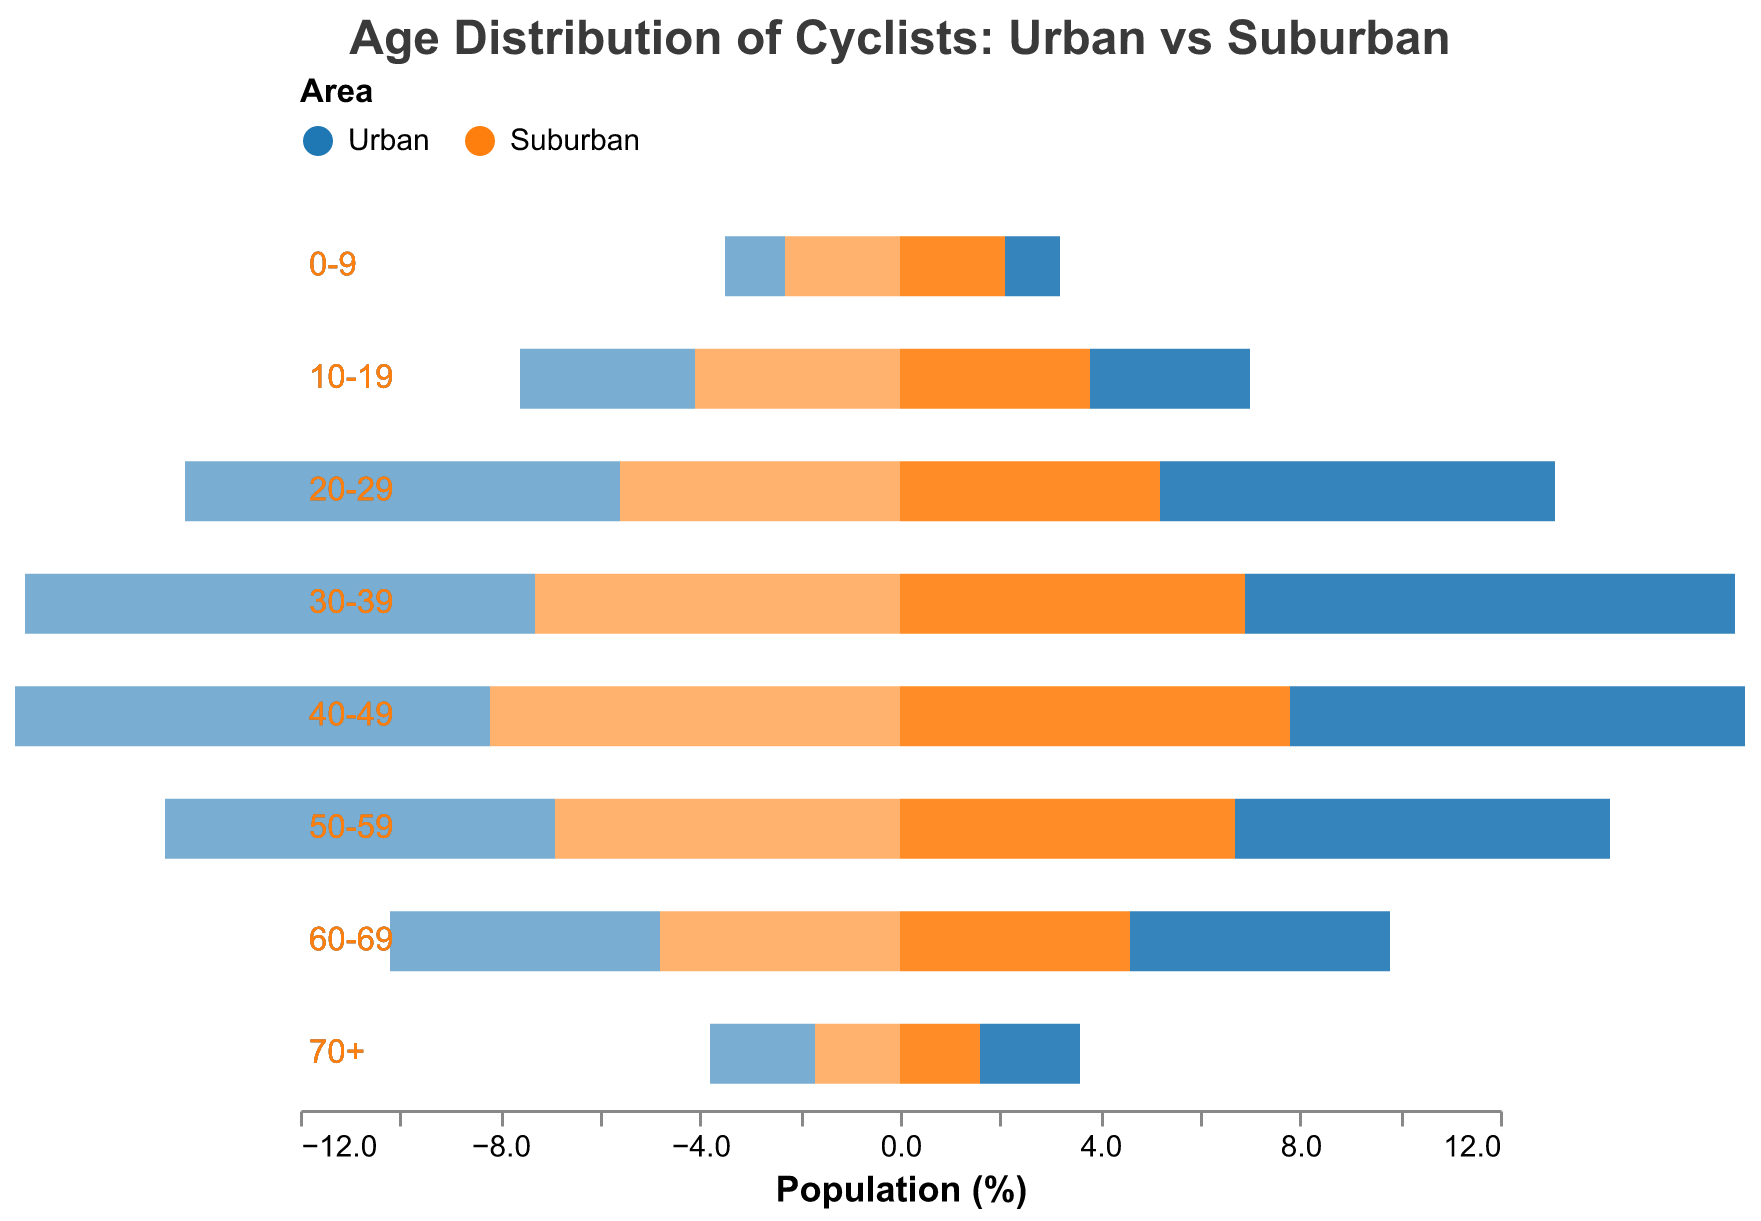What is the title of the figure? The title is located at the top of the figure, reading "Age Distribution of Cyclists: Urban vs Suburban".
Answer: Age Distribution of Cyclists: Urban vs Suburban How many age groups are presented in the figure? By looking at the y-axis, there are eight age groups displayed, ranging from "0-9" to "70+".
Answer: Eight Which area has a higher percentage of cyclists in the 30-39 age group, urban or suburban? By comparing the bar lengths for the 30-39 age group, the urban area has longer bars (10.2 for males and 9.8 for females versus 7.3 and 6.9 for suburban).
Answer: Urban In the 50-59 age group, is there more male or female cyclists in urban areas? For the 50-59 age group, compare the male and female urban bars. Urban male is 7.8% while urban female is 7.5%.
Answer: Male What is the difference in the percentage of urban male cyclists between the 20-29 and 60-69 age groups? Subtract the 60-69 percentage (5.4) from the 20-29 percentage (8.7).
Answer: 3.3 What is the combined percentage of suburban male and female cyclists in the 40-49 age group? Add the percentage of suburban males (8.2) and females (7.8) in the 40-49 age group.
Answer: 16 Which gender has a higher percentage across all age groups in suburban areas? Summing the percentages for each gender, males have higher values across all age groups in suburban areas.
Answer: Male What trend can you observe in the distribution of cyclists as age increases in urban areas? The percentage generally decreases as the age increases, indicating fewer older cyclists in urban areas.
Answer: Decreasing trend How does the percentage of cyclists in the 10-19 age group compare between urban and suburban areas? For the 10-19 age group, compare the combined percentages of urban (6.7) and suburban (7.9). The suburban area has a higher percentage.
Answer: Suburban has higher percentage What is the percentage difference of cyclists aged 70+ between urban males and suburban females? Subtract the suburban female percentage (1.6) from the urban male percentage (2.1).
Answer: 0.5 